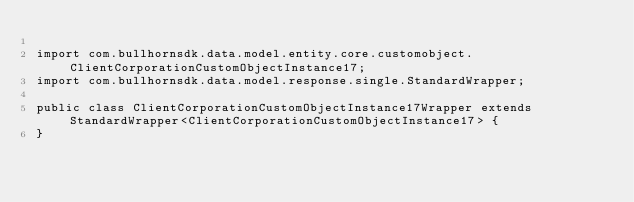Convert code to text. <code><loc_0><loc_0><loc_500><loc_500><_Java_>
import com.bullhornsdk.data.model.entity.core.customobject.ClientCorporationCustomObjectInstance17;
import com.bullhornsdk.data.model.response.single.StandardWrapper;

public class ClientCorporationCustomObjectInstance17Wrapper extends StandardWrapper<ClientCorporationCustomObjectInstance17> {
}
</code> 